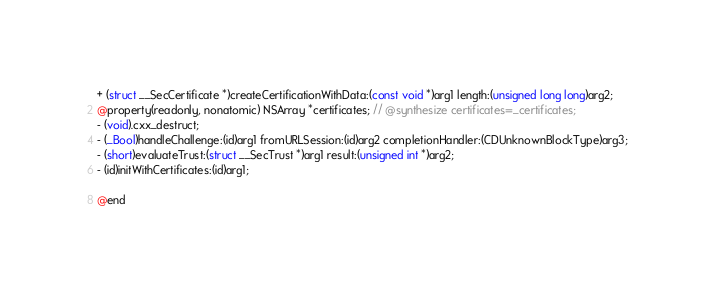<code> <loc_0><loc_0><loc_500><loc_500><_C_>
+ (struct __SecCertificate *)createCertificationWithData:(const void *)arg1 length:(unsigned long long)arg2;
@property(readonly, nonatomic) NSArray *certificates; // @synthesize certificates=_certificates;
- (void).cxx_destruct;
- (_Bool)handleChallenge:(id)arg1 fromURLSession:(id)arg2 completionHandler:(CDUnknownBlockType)arg3;
- (short)evaluateTrust:(struct __SecTrust *)arg1 result:(unsigned int *)arg2;
- (id)initWithCertificates:(id)arg1;

@end

</code> 